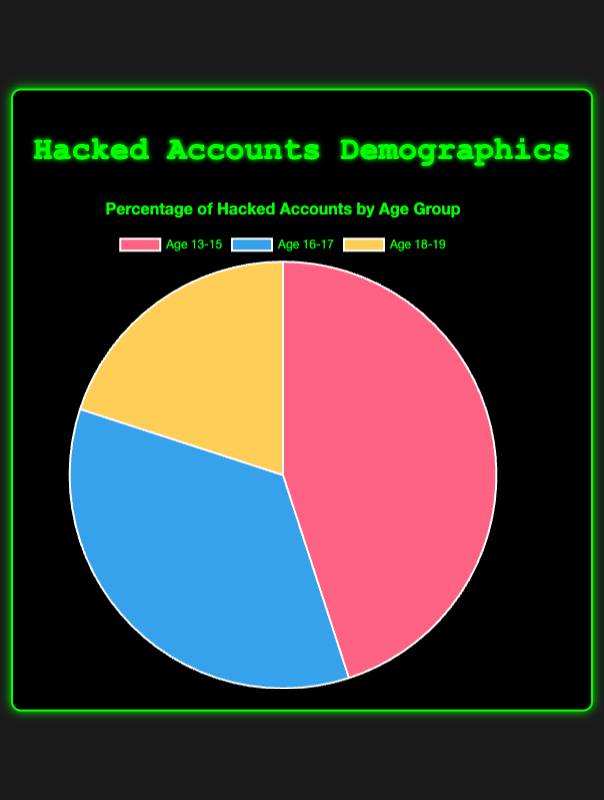What age group has the highest percentage of hacked accounts? The chart shows three age groups with different percentages. The group with the highest percentage of hacked accounts is 13-15, with 45%.
Answer: 13-15 What is the percentage difference between the age group 13-15 and 16-17? The percentage for age group 13-15 is 45% and for 16-17 is 35%. The difference is 45% - 35% = 10%.
Answer: 10% Which age group has the smallest percentage of hacked accounts, and what is that percentage? The chart shows that the age group 18-19 has the smallest percentage, which is 20%.
Answer: 18-19, 20% What is the total percentage of hacked accounts for ages 16-19? Add the percentages for the age groups 16-17 and 18-19: 35% + 20% = 55%.
Answer: 55% By how much does the percentage of hacked accounts for the age group 13-15 exceed that of 18-19? The percentage for 13-15 is 45% and for 18-19 is 20%. The difference is 45% - 20% = 25%.
Answer: 25% If the percentages were converted to absolute numbers, which age group would have the highest number of hacked accounts if the total number of hacked accounts was 1000? For 1000 total hacked accounts, the number for each group is found by multiplying the total by each percentage. For age 13-15: 1000 * 0.45 = 450. For age 16-17: 1000 * 0.35 = 350. For age 18-19: 1000 * 0.20 = 200. The group 13-15 has the highest number with 450 accounts.
Answer: 450 What is the combined percentage of hacked accounts across age groups with the highest usage of Instagram? The age groups 13-15 and 18-19 both commonly use Instagram. Adding their percentages: 45% + 20% = 65%.
Answer: 65% Among the age groups, which one has a slightly higher percentage of hacked accounts on TikTok and Twitter, and by what margin? The age group 16-17 has a slightly higher percentage compared to the other groups since they are the only group listed with TikTok and Twitter. The higher margin can be seen by comparing this percentage mainly with any other age group e.g. age group 18-19, showing a margin of 35% - 20% = 15%.
Answer: 16-17, 15% Which segment on the pie chart is represented by the color associated with the second-highest percentage? The second-highest percentage on the pie chart is for the age group 16-17, which is shown with the blue segment.
Answer: 16-17, blue Given that the average followers for each age group are 1200 (13-15), 2000 (16-17), and 1500 (18-19), which age group with a higher percentage of hacked accounts has fewer average followers? The age group 13-15 has the highest percentage of hacked accounts and fewer average followers (1200) than the age group 16-17 (2000).
Answer: 13-15, 1200 